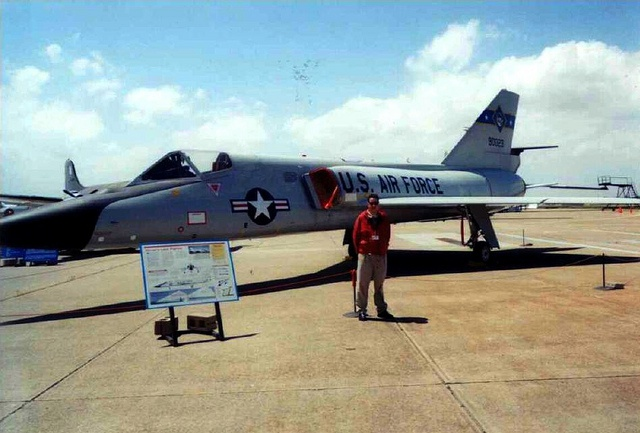Describe the objects in this image and their specific colors. I can see airplane in lightblue, black, navy, and gray tones and people in lightblue, black, maroon, gray, and darkgray tones in this image. 